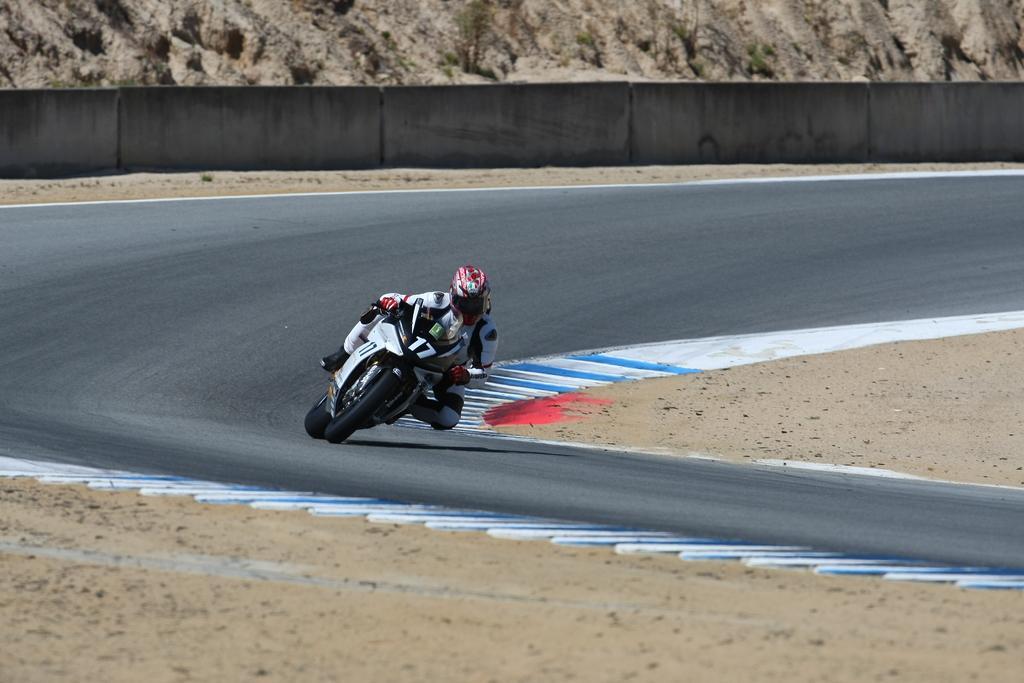In one or two sentences, can you explain what this image depicts? In this image I can see a person riding a motor bike on the road and at the top of the image there are rocks or sand 